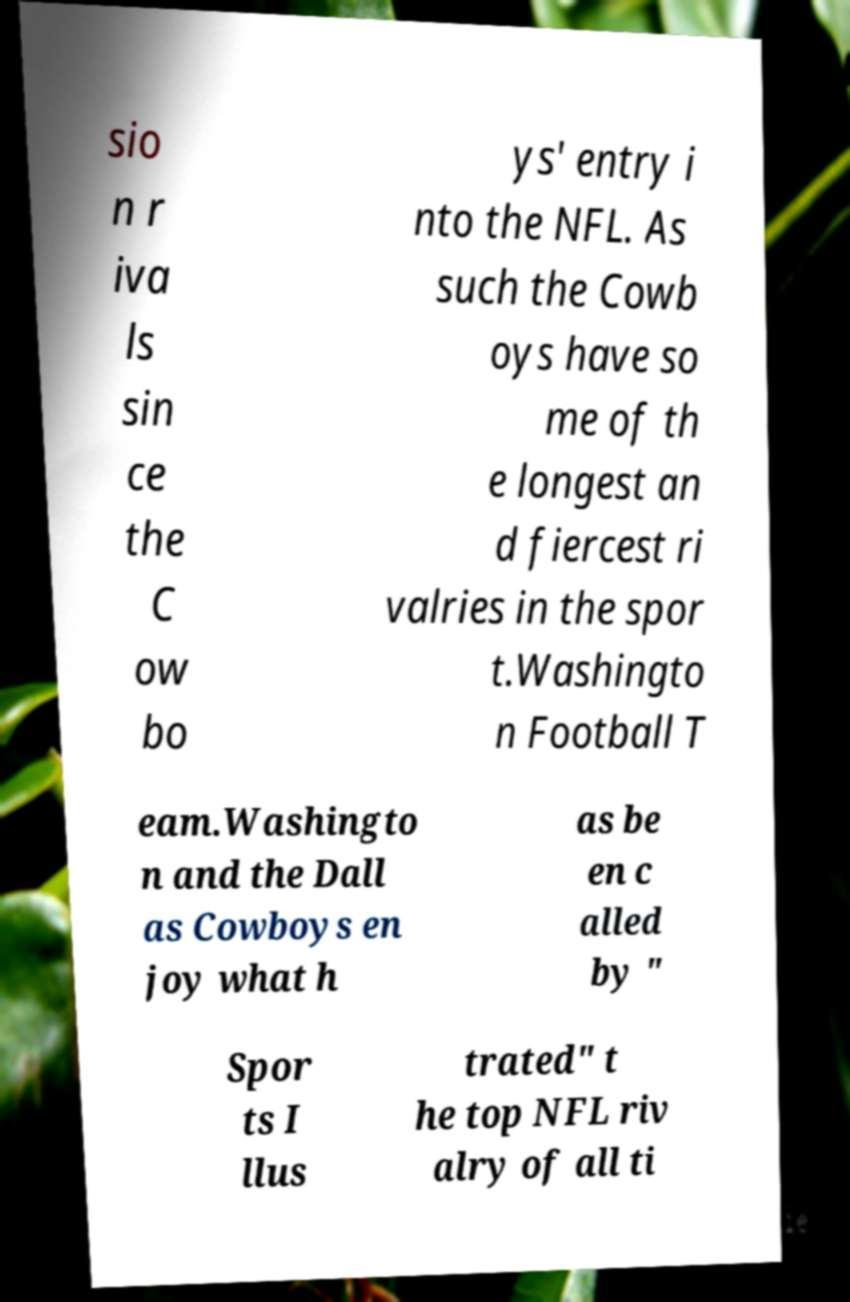What messages or text are displayed in this image? I need them in a readable, typed format. sio n r iva ls sin ce the C ow bo ys' entry i nto the NFL. As such the Cowb oys have so me of th e longest an d fiercest ri valries in the spor t.Washingto n Football T eam.Washingto n and the Dall as Cowboys en joy what h as be en c alled by " Spor ts I llus trated" t he top NFL riv alry of all ti 